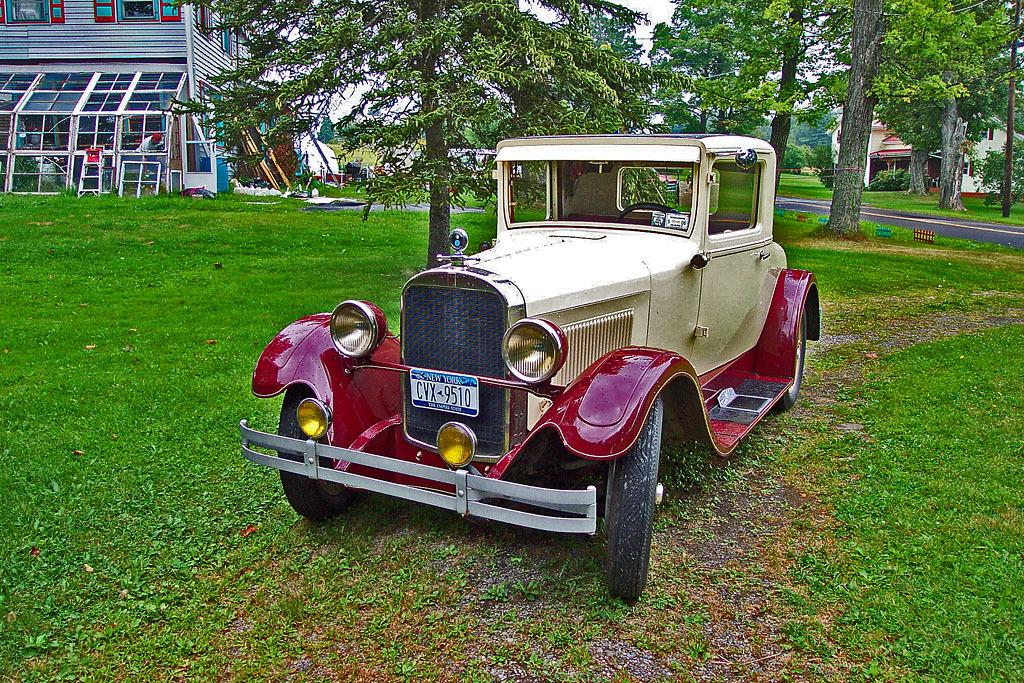What type of vehicle is on the grass lawn in the image? There is a jeep with a number plate on a grass lawn in the image. What can be seen in the background of the image? There are trees, a road, and two buildings with windows in the background. What type of surface is the jeep parked on? The jeep is parked on a grass lawn. Can you describe the buildings in the background? There are two buildings in the background, both with windows. What advice is the mother giving to her child during the development of the battle in the image? There is no mother, development, or battle present in the image. The image features a jeep on a grass lawn with trees, a road, and buildings in the background. 